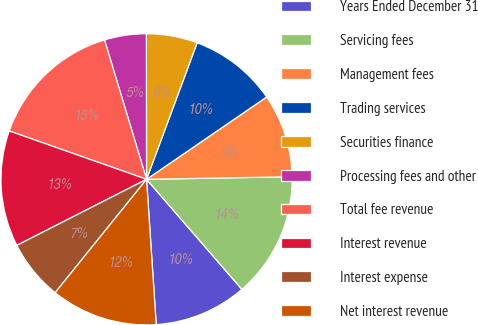Convert chart. <chart><loc_0><loc_0><loc_500><loc_500><pie_chart><fcel>Years Ended December 31<fcel>Servicing fees<fcel>Management fees<fcel>Trading services<fcel>Securities finance<fcel>Processing fees and other<fcel>Total fee revenue<fcel>Interest revenue<fcel>Interest expense<fcel>Net interest revenue<nl><fcel>10.31%<fcel>13.92%<fcel>9.28%<fcel>9.79%<fcel>5.67%<fcel>4.64%<fcel>14.95%<fcel>12.89%<fcel>6.7%<fcel>11.86%<nl></chart> 